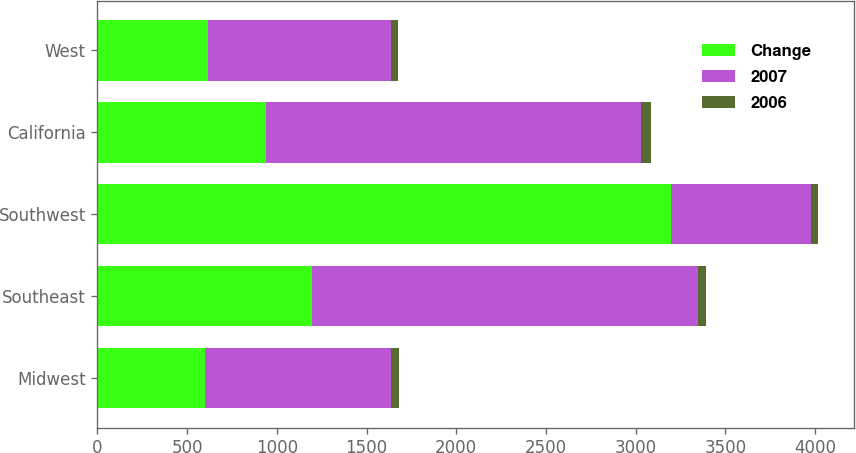Convert chart to OTSL. <chart><loc_0><loc_0><loc_500><loc_500><stacked_bar_chart><ecel><fcel>Midwest<fcel>Southeast<fcel>Southwest<fcel>California<fcel>West<nl><fcel>Change<fcel>600<fcel>1198<fcel>3198<fcel>941<fcel>618<nl><fcel>2007<fcel>1037<fcel>2148<fcel>779.5<fcel>2088<fcel>1020<nl><fcel>2006<fcel>42<fcel>44<fcel>41<fcel>55<fcel>39<nl></chart> 